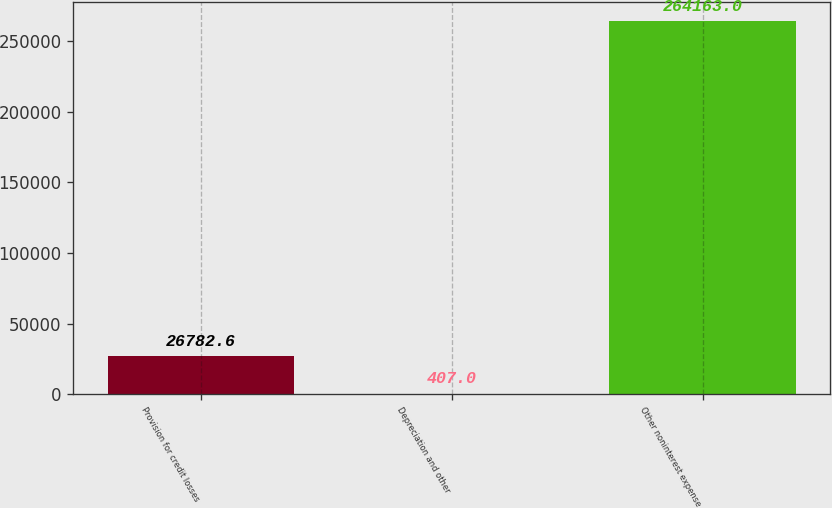Convert chart. <chart><loc_0><loc_0><loc_500><loc_500><bar_chart><fcel>Provision for credit losses<fcel>Depreciation and other<fcel>Other noninterest expense<nl><fcel>26782.6<fcel>407<fcel>264163<nl></chart> 